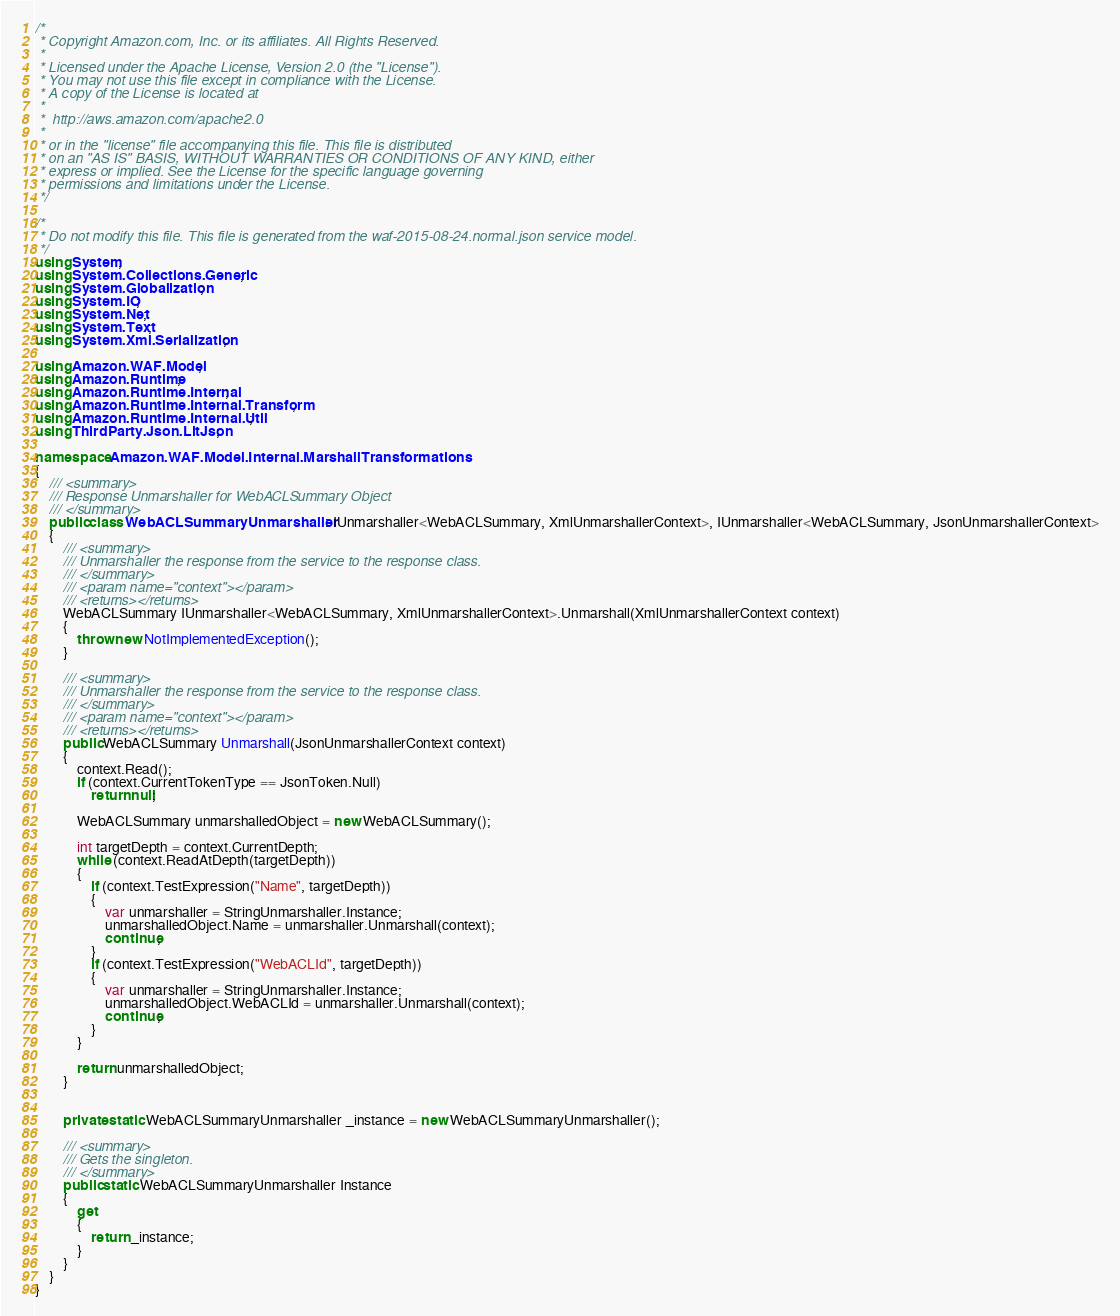<code> <loc_0><loc_0><loc_500><loc_500><_C#_>/*
 * Copyright Amazon.com, Inc. or its affiliates. All Rights Reserved.
 * 
 * Licensed under the Apache License, Version 2.0 (the "License").
 * You may not use this file except in compliance with the License.
 * A copy of the License is located at
 * 
 *  http://aws.amazon.com/apache2.0
 * 
 * or in the "license" file accompanying this file. This file is distributed
 * on an "AS IS" BASIS, WITHOUT WARRANTIES OR CONDITIONS OF ANY KIND, either
 * express or implied. See the License for the specific language governing
 * permissions and limitations under the License.
 */

/*
 * Do not modify this file. This file is generated from the waf-2015-08-24.normal.json service model.
 */
using System;
using System.Collections.Generic;
using System.Globalization;
using System.IO;
using System.Net;
using System.Text;
using System.Xml.Serialization;

using Amazon.WAF.Model;
using Amazon.Runtime;
using Amazon.Runtime.Internal;
using Amazon.Runtime.Internal.Transform;
using Amazon.Runtime.Internal.Util;
using ThirdParty.Json.LitJson;

namespace Amazon.WAF.Model.Internal.MarshallTransformations
{
    /// <summary>
    /// Response Unmarshaller for WebACLSummary Object
    /// </summary>  
    public class WebACLSummaryUnmarshaller : IUnmarshaller<WebACLSummary, XmlUnmarshallerContext>, IUnmarshaller<WebACLSummary, JsonUnmarshallerContext>
    {
        /// <summary>
        /// Unmarshaller the response from the service to the response class.
        /// </summary>  
        /// <param name="context"></param>
        /// <returns></returns>
        WebACLSummary IUnmarshaller<WebACLSummary, XmlUnmarshallerContext>.Unmarshall(XmlUnmarshallerContext context)
        {
            throw new NotImplementedException();
        }

        /// <summary>
        /// Unmarshaller the response from the service to the response class.
        /// </summary>  
        /// <param name="context"></param>
        /// <returns></returns>
        public WebACLSummary Unmarshall(JsonUnmarshallerContext context)
        {
            context.Read();
            if (context.CurrentTokenType == JsonToken.Null) 
                return null;

            WebACLSummary unmarshalledObject = new WebACLSummary();
        
            int targetDepth = context.CurrentDepth;
            while (context.ReadAtDepth(targetDepth))
            {
                if (context.TestExpression("Name", targetDepth))
                {
                    var unmarshaller = StringUnmarshaller.Instance;
                    unmarshalledObject.Name = unmarshaller.Unmarshall(context);
                    continue;
                }
                if (context.TestExpression("WebACLId", targetDepth))
                {
                    var unmarshaller = StringUnmarshaller.Instance;
                    unmarshalledObject.WebACLId = unmarshaller.Unmarshall(context);
                    continue;
                }
            }
          
            return unmarshalledObject;
        }


        private static WebACLSummaryUnmarshaller _instance = new WebACLSummaryUnmarshaller();        

        /// <summary>
        /// Gets the singleton.
        /// </summary>  
        public static WebACLSummaryUnmarshaller Instance
        {
            get
            {
                return _instance;
            }
        }
    }
}</code> 